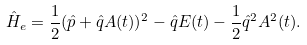<formula> <loc_0><loc_0><loc_500><loc_500>\hat { H } _ { e } = \frac { 1 } { 2 } ( \hat { p } + \hat { q } A ( t ) ) ^ { 2 } - \hat { q } E ( t ) - \frac { 1 } { 2 } \hat { q } ^ { 2 } A ^ { 2 } ( t ) .</formula> 